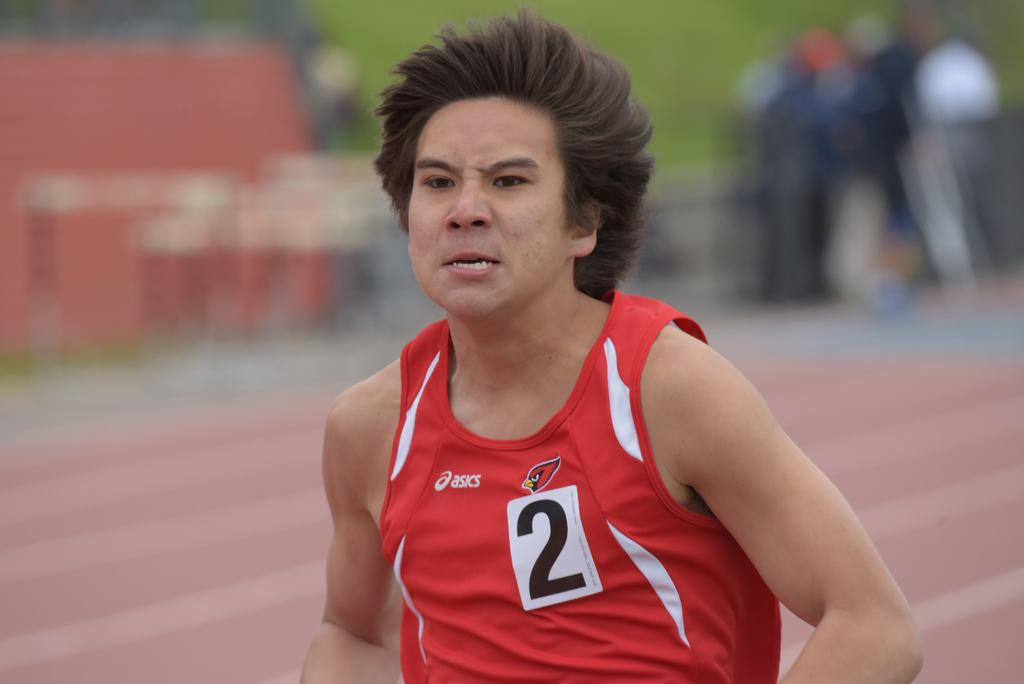<image>
Describe the image concisely. A runner wearing a red tank top with the number 2 is giving it his all. 